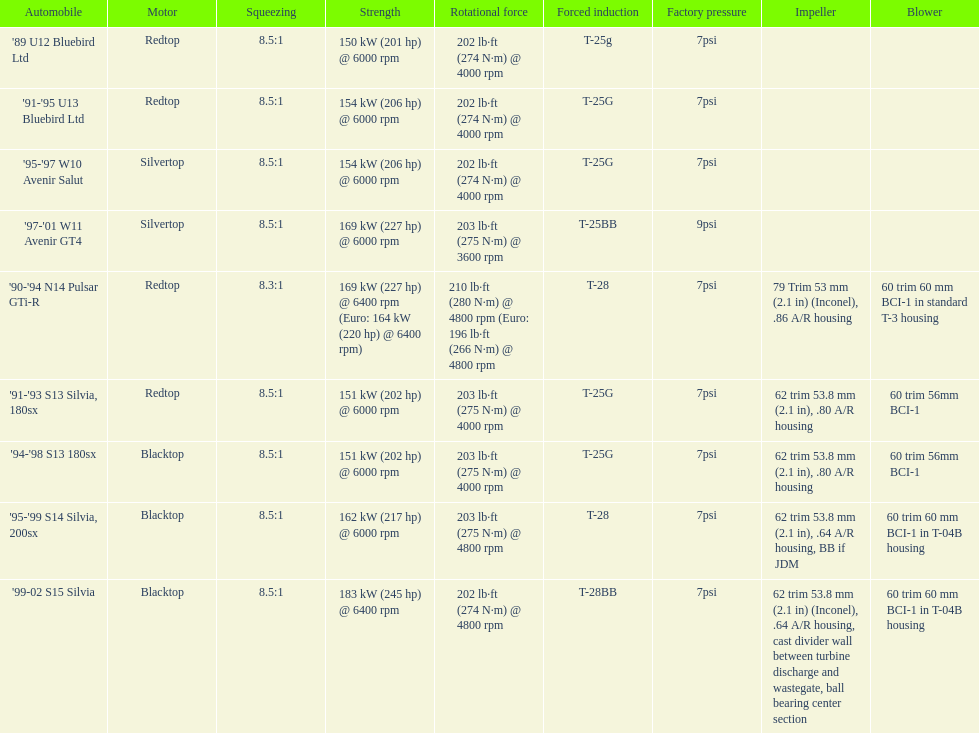Which automobile has a standard boost of over 7psi? '97-'01 W11 Avenir GT4. 